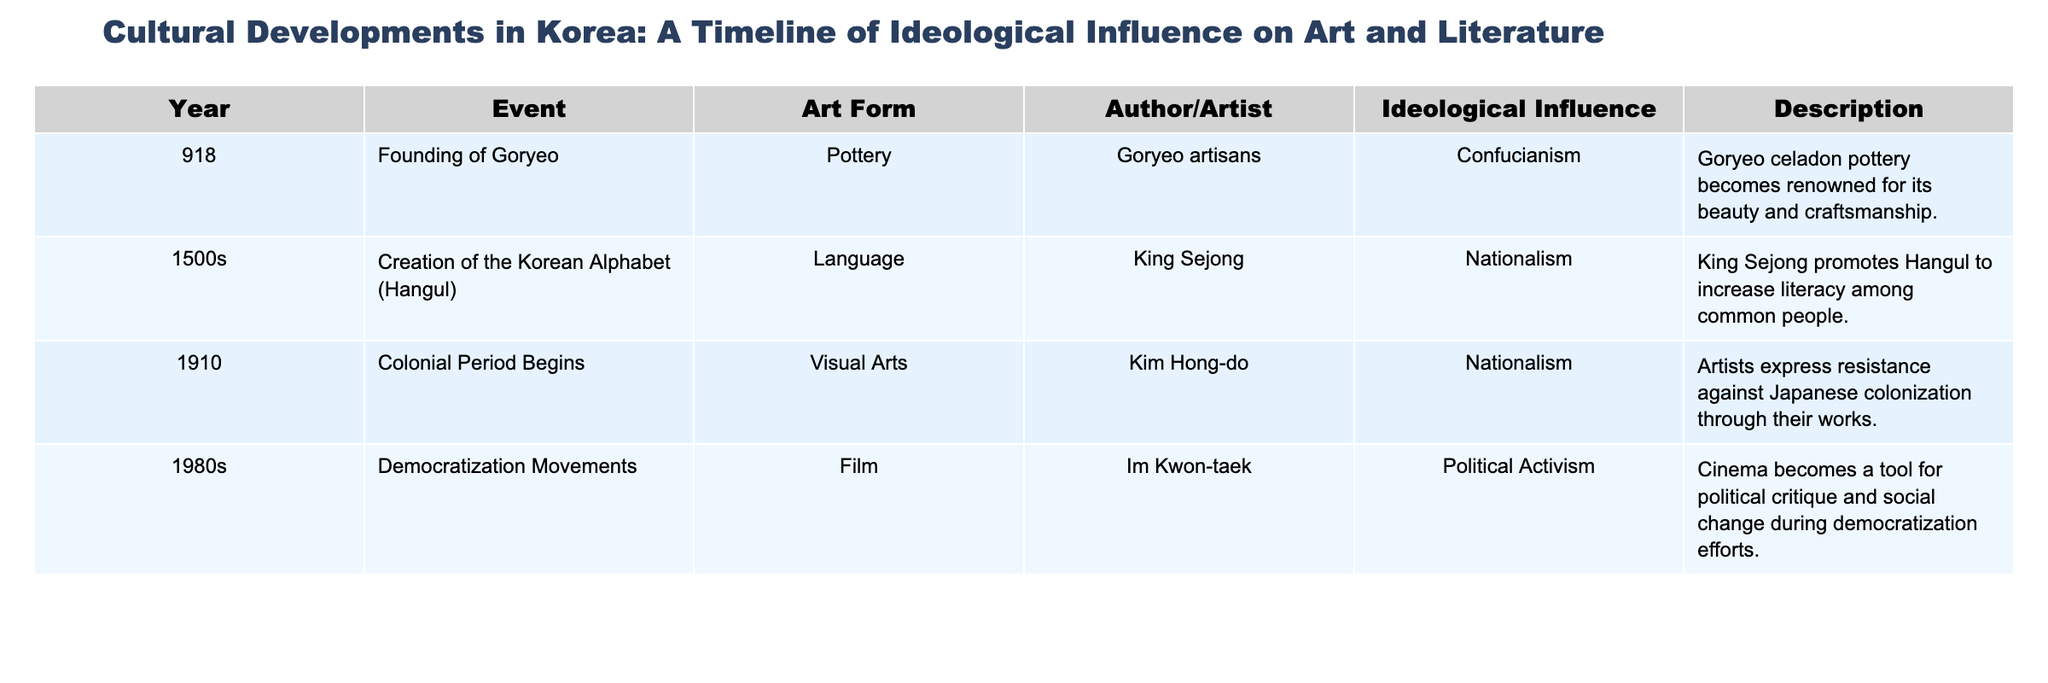What year did the Goryeo dynasty begin? The table states that the founding of Goryeo took place in the year 918.
Answer: 918 Who was the artist associated with Hangul creation? According to the table, King Sejong is credited as the author for the creation of the Korean Alphabet (Hangul).
Answer: King Sejong What art form did Kim Hong-do work in during the colonial period? The table lists Kim Hong-do as a visual arts artist during the colonial period which began in 1910.
Answer: Visual Arts In what decade did democratization movements in Korea take place? The table indicates that the democratization movements occurred in the 1980s.
Answer: 1980s Did the event of creating the Korean alphabet influence nationalism? Yes, the table states that the creation of Hangul during the 1500s had a nationalistic ideological influence.
Answer: Yes What is the ideological influence of Goryeo celadon pottery? The table specifies that Goryeo celadon pottery reflects Confucianism as its ideological influence.
Answer: Confucianism Which event is linked to political activism in film? The table describes the democratization movements in the 1980s as the event linked to political activism in film, represented by Im Kwon-taek's work.
Answer: Democratization movements How many events listed in the table have a nationalistic ideological influence? There are three events (the creation of Hangul, the colonial period, and the founding of Goryeo) that exhibit nationalistic ideological influence when counted.
Answer: 3 What is the first event listed concerning ideological influence? The first event listed in the table is the founding of Goryeo in 918, which concerns ideological influence.
Answer: Founding of Goryeo How does the approach to art change from the Goryeo period to the colonial period based on ideological influences? The Goryeo period influenced art with Confucianism focusing on beauty and craftsmanship, while the colonial period saw nationalism as a response to oppression, resulting in resistance-themed works.
Answer: From Confucianism to Nationalism 